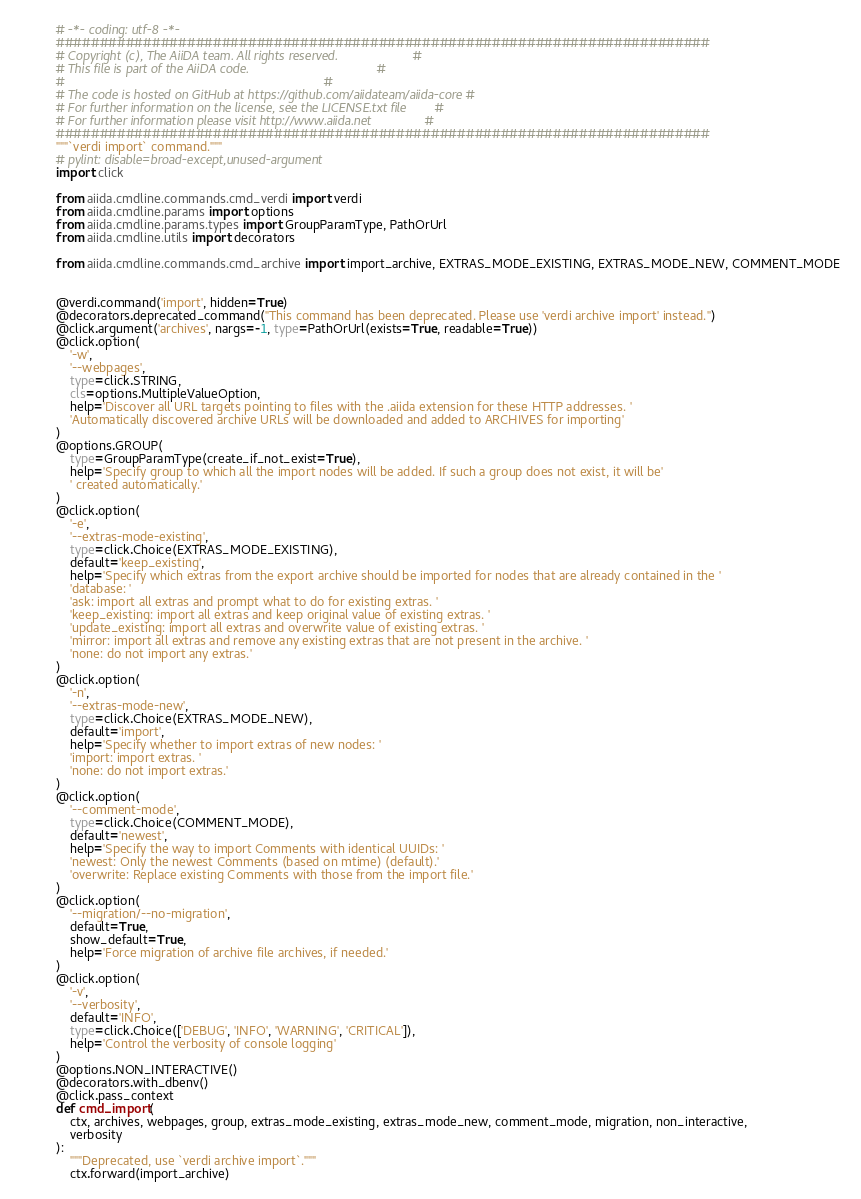<code> <loc_0><loc_0><loc_500><loc_500><_Python_># -*- coding: utf-8 -*-
###########################################################################
# Copyright (c), The AiiDA team. All rights reserved.                     #
# This file is part of the AiiDA code.                                    #
#                                                                         #
# The code is hosted on GitHub at https://github.com/aiidateam/aiida-core #
# For further information on the license, see the LICENSE.txt file        #
# For further information please visit http://www.aiida.net               #
###########################################################################
"""`verdi import` command."""
# pylint: disable=broad-except,unused-argument
import click

from aiida.cmdline.commands.cmd_verdi import verdi
from aiida.cmdline.params import options
from aiida.cmdline.params.types import GroupParamType, PathOrUrl
from aiida.cmdline.utils import decorators

from aiida.cmdline.commands.cmd_archive import import_archive, EXTRAS_MODE_EXISTING, EXTRAS_MODE_NEW, COMMENT_MODE


@verdi.command('import', hidden=True)
@decorators.deprecated_command("This command has been deprecated. Please use 'verdi archive import' instead.")
@click.argument('archives', nargs=-1, type=PathOrUrl(exists=True, readable=True))
@click.option(
    '-w',
    '--webpages',
    type=click.STRING,
    cls=options.MultipleValueOption,
    help='Discover all URL targets pointing to files with the .aiida extension for these HTTP addresses. '
    'Automatically discovered archive URLs will be downloaded and added to ARCHIVES for importing'
)
@options.GROUP(
    type=GroupParamType(create_if_not_exist=True),
    help='Specify group to which all the import nodes will be added. If such a group does not exist, it will be'
    ' created automatically.'
)
@click.option(
    '-e',
    '--extras-mode-existing',
    type=click.Choice(EXTRAS_MODE_EXISTING),
    default='keep_existing',
    help='Specify which extras from the export archive should be imported for nodes that are already contained in the '
    'database: '
    'ask: import all extras and prompt what to do for existing extras. '
    'keep_existing: import all extras and keep original value of existing extras. '
    'update_existing: import all extras and overwrite value of existing extras. '
    'mirror: import all extras and remove any existing extras that are not present in the archive. '
    'none: do not import any extras.'
)
@click.option(
    '-n',
    '--extras-mode-new',
    type=click.Choice(EXTRAS_MODE_NEW),
    default='import',
    help='Specify whether to import extras of new nodes: '
    'import: import extras. '
    'none: do not import extras.'
)
@click.option(
    '--comment-mode',
    type=click.Choice(COMMENT_MODE),
    default='newest',
    help='Specify the way to import Comments with identical UUIDs: '
    'newest: Only the newest Comments (based on mtime) (default).'
    'overwrite: Replace existing Comments with those from the import file.'
)
@click.option(
    '--migration/--no-migration',
    default=True,
    show_default=True,
    help='Force migration of archive file archives, if needed.'
)
@click.option(
    '-v',
    '--verbosity',
    default='INFO',
    type=click.Choice(['DEBUG', 'INFO', 'WARNING', 'CRITICAL']),
    help='Control the verbosity of console logging'
)
@options.NON_INTERACTIVE()
@decorators.with_dbenv()
@click.pass_context
def cmd_import(
    ctx, archives, webpages, group, extras_mode_existing, extras_mode_new, comment_mode, migration, non_interactive,
    verbosity
):
    """Deprecated, use `verdi archive import`."""
    ctx.forward(import_archive)
</code> 